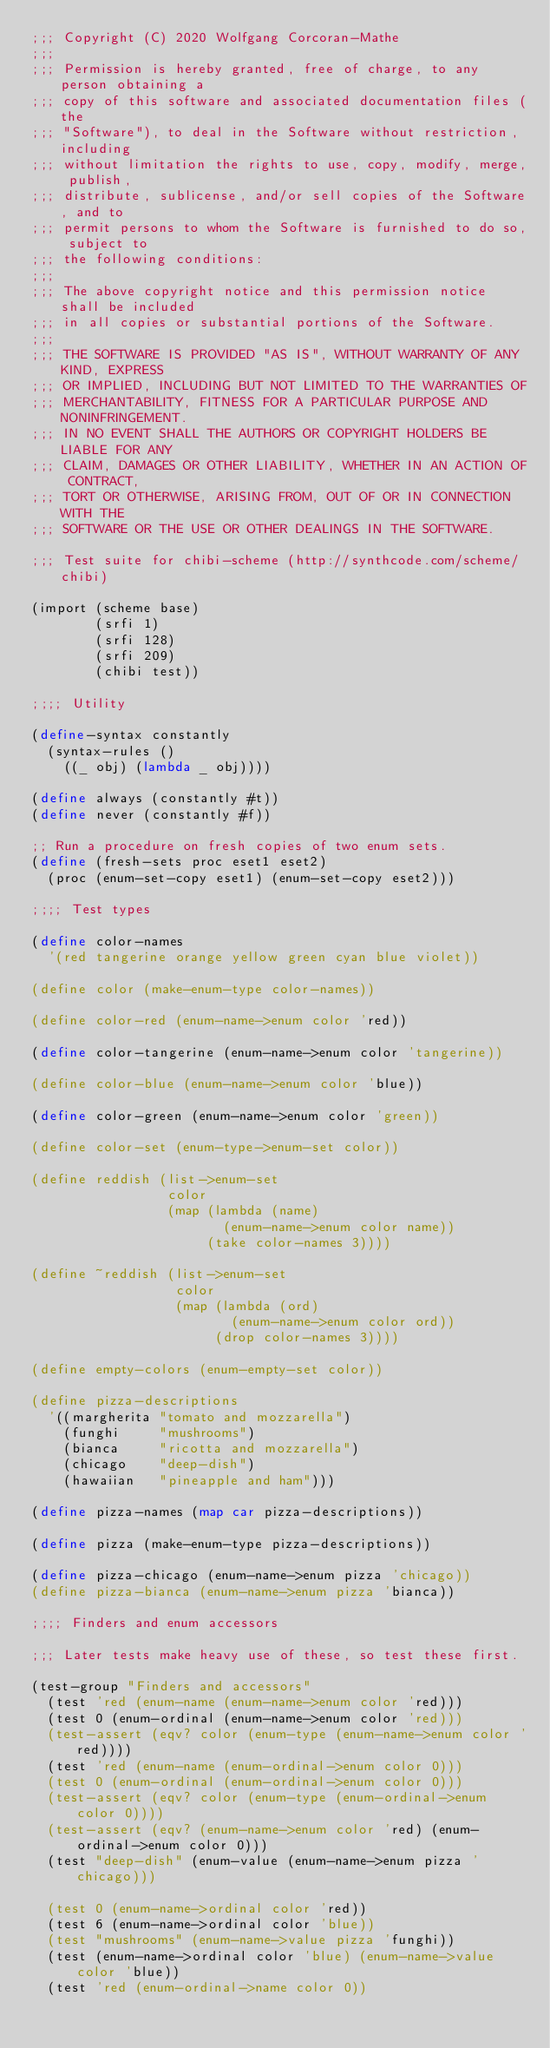<code> <loc_0><loc_0><loc_500><loc_500><_Scheme_>;;; Copyright (C) 2020 Wolfgang Corcoran-Mathe
;;;
;;; Permission is hereby granted, free of charge, to any person obtaining a
;;; copy of this software and associated documentation files (the
;;; "Software"), to deal in the Software without restriction, including
;;; without limitation the rights to use, copy, modify, merge, publish,
;;; distribute, sublicense, and/or sell copies of the Software, and to
;;; permit persons to whom the Software is furnished to do so, subject to
;;; the following conditions:
;;;
;;; The above copyright notice and this permission notice shall be included
;;; in all copies or substantial portions of the Software.
;;;
;;; THE SOFTWARE IS PROVIDED "AS IS", WITHOUT WARRANTY OF ANY KIND, EXPRESS
;;; OR IMPLIED, INCLUDING BUT NOT LIMITED TO THE WARRANTIES OF
;;; MERCHANTABILITY, FITNESS FOR A PARTICULAR PURPOSE AND NONINFRINGEMENT.
;;; IN NO EVENT SHALL THE AUTHORS OR COPYRIGHT HOLDERS BE LIABLE FOR ANY
;;; CLAIM, DAMAGES OR OTHER LIABILITY, WHETHER IN AN ACTION OF CONTRACT,
;;; TORT OR OTHERWISE, ARISING FROM, OUT OF OR IN CONNECTION WITH THE
;;; SOFTWARE OR THE USE OR OTHER DEALINGS IN THE SOFTWARE.

;;; Test suite for chibi-scheme (http://synthcode.com/scheme/chibi)

(import (scheme base)
        (srfi 1)
        (srfi 128)
        (srfi 209)
        (chibi test))

;;;; Utility

(define-syntax constantly
  (syntax-rules ()
    ((_ obj) (lambda _ obj))))

(define always (constantly #t))
(define never (constantly #f))

;; Run a procedure on fresh copies of two enum sets.
(define (fresh-sets proc eset1 eset2)
  (proc (enum-set-copy eset1) (enum-set-copy eset2)))

;;;; Test types

(define color-names
  '(red tangerine orange yellow green cyan blue violet))

(define color (make-enum-type color-names))

(define color-red (enum-name->enum color 'red))

(define color-tangerine (enum-name->enum color 'tangerine))

(define color-blue (enum-name->enum color 'blue))

(define color-green (enum-name->enum color 'green))

(define color-set (enum-type->enum-set color))

(define reddish (list->enum-set
                 color
                 (map (lambda (name)
                        (enum-name->enum color name))
                      (take color-names 3))))

(define ~reddish (list->enum-set
                  color
                  (map (lambda (ord)
                         (enum-name->enum color ord))
                       (drop color-names 3))))

(define empty-colors (enum-empty-set color))

(define pizza-descriptions
  '((margherita "tomato and mozzarella")
    (funghi     "mushrooms")
    (bianca     "ricotta and mozzarella")
    (chicago    "deep-dish")
    (hawaiian   "pineapple and ham")))

(define pizza-names (map car pizza-descriptions))

(define pizza (make-enum-type pizza-descriptions))

(define pizza-chicago (enum-name->enum pizza 'chicago))
(define pizza-bianca (enum-name->enum pizza 'bianca))

;;;; Finders and enum accessors

;;; Later tests make heavy use of these, so test these first.

(test-group "Finders and accessors"
  (test 'red (enum-name (enum-name->enum color 'red)))
  (test 0 (enum-ordinal (enum-name->enum color 'red)))
  (test-assert (eqv? color (enum-type (enum-name->enum color 'red))))
  (test 'red (enum-name (enum-ordinal->enum color 0)))
  (test 0 (enum-ordinal (enum-ordinal->enum color 0)))
  (test-assert (eqv? color (enum-type (enum-ordinal->enum color 0))))
  (test-assert (eqv? (enum-name->enum color 'red) (enum-ordinal->enum color 0)))
  (test "deep-dish" (enum-value (enum-name->enum pizza 'chicago)))

  (test 0 (enum-name->ordinal color 'red))
  (test 6 (enum-name->ordinal color 'blue))
  (test "mushrooms" (enum-name->value pizza 'funghi))
  (test (enum-name->ordinal color 'blue) (enum-name->value color 'blue))
  (test 'red (enum-ordinal->name color 0))</code> 